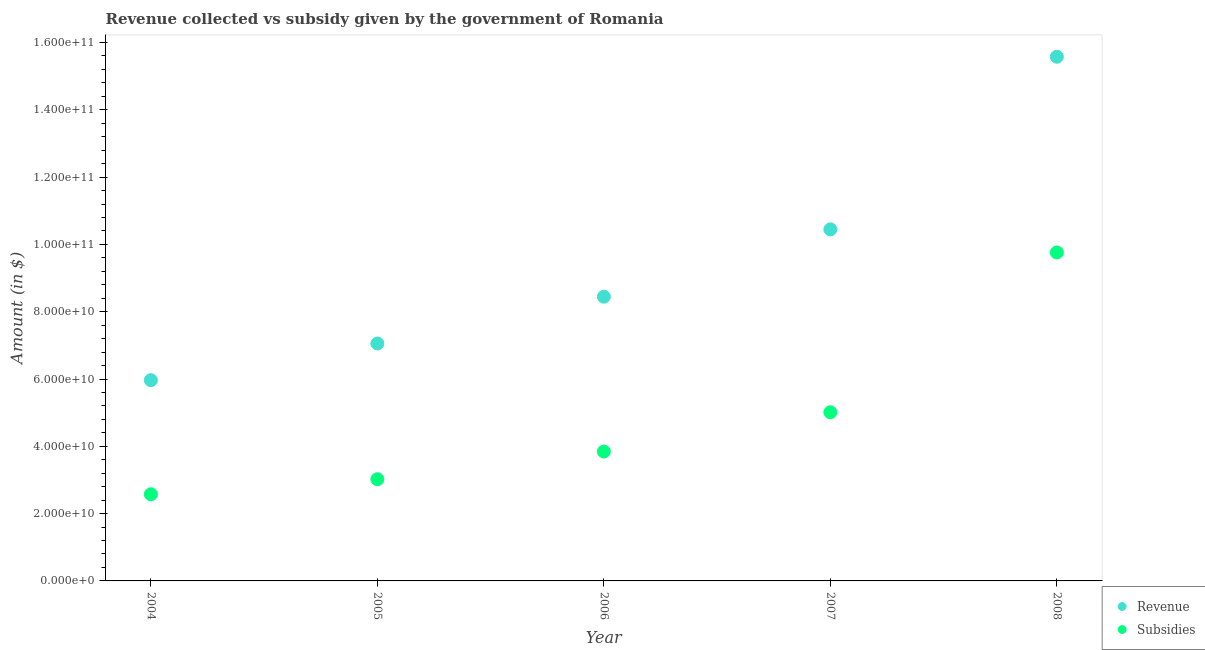How many different coloured dotlines are there?
Your answer should be very brief. 2. Is the number of dotlines equal to the number of legend labels?
Your answer should be very brief. Yes. What is the amount of subsidies given in 2007?
Offer a very short reply. 5.01e+1. Across all years, what is the maximum amount of subsidies given?
Your answer should be compact. 9.76e+1. Across all years, what is the minimum amount of subsidies given?
Ensure brevity in your answer.  2.57e+1. What is the total amount of subsidies given in the graph?
Your answer should be very brief. 2.42e+11. What is the difference between the amount of subsidies given in 2005 and that in 2008?
Provide a short and direct response. -6.74e+1. What is the difference between the amount of subsidies given in 2007 and the amount of revenue collected in 2004?
Your response must be concise. -9.53e+09. What is the average amount of subsidies given per year?
Your answer should be very brief. 4.84e+1. In the year 2006, what is the difference between the amount of revenue collected and amount of subsidies given?
Offer a very short reply. 4.60e+1. In how many years, is the amount of subsidies given greater than 68000000000 $?
Make the answer very short. 1. What is the ratio of the amount of subsidies given in 2006 to that in 2008?
Your response must be concise. 0.39. Is the difference between the amount of revenue collected in 2004 and 2005 greater than the difference between the amount of subsidies given in 2004 and 2005?
Your response must be concise. No. What is the difference between the highest and the second highest amount of subsidies given?
Your answer should be compact. 4.75e+1. What is the difference between the highest and the lowest amount of revenue collected?
Offer a very short reply. 9.61e+1. Does the amount of subsidies given monotonically increase over the years?
Offer a terse response. Yes. What is the difference between two consecutive major ticks on the Y-axis?
Make the answer very short. 2.00e+1. Where does the legend appear in the graph?
Your answer should be compact. Bottom right. What is the title of the graph?
Provide a succinct answer. Revenue collected vs subsidy given by the government of Romania. Does "Ages 15-24" appear as one of the legend labels in the graph?
Your answer should be compact. No. What is the label or title of the Y-axis?
Ensure brevity in your answer.  Amount (in $). What is the Amount (in $) in Revenue in 2004?
Your answer should be very brief. 5.96e+1. What is the Amount (in $) in Subsidies in 2004?
Provide a succinct answer. 2.57e+1. What is the Amount (in $) of Revenue in 2005?
Offer a terse response. 7.06e+1. What is the Amount (in $) of Subsidies in 2005?
Give a very brief answer. 3.02e+1. What is the Amount (in $) of Revenue in 2006?
Keep it short and to the point. 8.45e+1. What is the Amount (in $) in Subsidies in 2006?
Ensure brevity in your answer.  3.84e+1. What is the Amount (in $) of Revenue in 2007?
Your answer should be compact. 1.04e+11. What is the Amount (in $) of Subsidies in 2007?
Give a very brief answer. 5.01e+1. What is the Amount (in $) of Revenue in 2008?
Offer a terse response. 1.56e+11. What is the Amount (in $) of Subsidies in 2008?
Your answer should be very brief. 9.76e+1. Across all years, what is the maximum Amount (in $) in Revenue?
Keep it short and to the point. 1.56e+11. Across all years, what is the maximum Amount (in $) in Subsidies?
Offer a terse response. 9.76e+1. Across all years, what is the minimum Amount (in $) of Revenue?
Your answer should be very brief. 5.96e+1. Across all years, what is the minimum Amount (in $) of Subsidies?
Provide a succinct answer. 2.57e+1. What is the total Amount (in $) of Revenue in the graph?
Your response must be concise. 4.75e+11. What is the total Amount (in $) in Subsidies in the graph?
Make the answer very short. 2.42e+11. What is the difference between the Amount (in $) in Revenue in 2004 and that in 2005?
Your answer should be compact. -1.09e+1. What is the difference between the Amount (in $) of Subsidies in 2004 and that in 2005?
Your answer should be compact. -4.48e+09. What is the difference between the Amount (in $) of Revenue in 2004 and that in 2006?
Provide a succinct answer. -2.48e+1. What is the difference between the Amount (in $) in Subsidies in 2004 and that in 2006?
Give a very brief answer. -1.27e+1. What is the difference between the Amount (in $) of Revenue in 2004 and that in 2007?
Provide a short and direct response. -4.48e+1. What is the difference between the Amount (in $) of Subsidies in 2004 and that in 2007?
Make the answer very short. -2.44e+1. What is the difference between the Amount (in $) of Revenue in 2004 and that in 2008?
Offer a very short reply. -9.61e+1. What is the difference between the Amount (in $) of Subsidies in 2004 and that in 2008?
Your answer should be compact. -7.19e+1. What is the difference between the Amount (in $) in Revenue in 2005 and that in 2006?
Your answer should be compact. -1.39e+1. What is the difference between the Amount (in $) in Subsidies in 2005 and that in 2006?
Your answer should be compact. -8.22e+09. What is the difference between the Amount (in $) of Revenue in 2005 and that in 2007?
Your answer should be very brief. -3.39e+1. What is the difference between the Amount (in $) in Subsidies in 2005 and that in 2007?
Give a very brief answer. -1.99e+1. What is the difference between the Amount (in $) of Revenue in 2005 and that in 2008?
Offer a very short reply. -8.52e+1. What is the difference between the Amount (in $) of Subsidies in 2005 and that in 2008?
Keep it short and to the point. -6.74e+1. What is the difference between the Amount (in $) of Revenue in 2006 and that in 2007?
Your answer should be compact. -2.00e+1. What is the difference between the Amount (in $) of Subsidies in 2006 and that in 2007?
Your response must be concise. -1.17e+1. What is the difference between the Amount (in $) in Revenue in 2006 and that in 2008?
Offer a terse response. -7.13e+1. What is the difference between the Amount (in $) of Subsidies in 2006 and that in 2008?
Offer a very short reply. -5.92e+1. What is the difference between the Amount (in $) in Revenue in 2007 and that in 2008?
Your answer should be very brief. -5.13e+1. What is the difference between the Amount (in $) in Subsidies in 2007 and that in 2008?
Keep it short and to the point. -4.75e+1. What is the difference between the Amount (in $) in Revenue in 2004 and the Amount (in $) in Subsidies in 2005?
Your answer should be very brief. 2.94e+1. What is the difference between the Amount (in $) of Revenue in 2004 and the Amount (in $) of Subsidies in 2006?
Provide a succinct answer. 2.12e+1. What is the difference between the Amount (in $) of Revenue in 2004 and the Amount (in $) of Subsidies in 2007?
Provide a succinct answer. 9.53e+09. What is the difference between the Amount (in $) of Revenue in 2004 and the Amount (in $) of Subsidies in 2008?
Your answer should be compact. -3.80e+1. What is the difference between the Amount (in $) in Revenue in 2005 and the Amount (in $) in Subsidies in 2006?
Offer a very short reply. 3.21e+1. What is the difference between the Amount (in $) of Revenue in 2005 and the Amount (in $) of Subsidies in 2007?
Make the answer very short. 2.04e+1. What is the difference between the Amount (in $) of Revenue in 2005 and the Amount (in $) of Subsidies in 2008?
Provide a succinct answer. -2.71e+1. What is the difference between the Amount (in $) in Revenue in 2006 and the Amount (in $) in Subsidies in 2007?
Your response must be concise. 3.43e+1. What is the difference between the Amount (in $) in Revenue in 2006 and the Amount (in $) in Subsidies in 2008?
Ensure brevity in your answer.  -1.31e+1. What is the difference between the Amount (in $) of Revenue in 2007 and the Amount (in $) of Subsidies in 2008?
Provide a short and direct response. 6.87e+09. What is the average Amount (in $) in Revenue per year?
Your response must be concise. 9.50e+1. What is the average Amount (in $) of Subsidies per year?
Keep it short and to the point. 4.84e+1. In the year 2004, what is the difference between the Amount (in $) in Revenue and Amount (in $) in Subsidies?
Provide a succinct answer. 3.39e+1. In the year 2005, what is the difference between the Amount (in $) of Revenue and Amount (in $) of Subsidies?
Offer a terse response. 4.03e+1. In the year 2006, what is the difference between the Amount (in $) in Revenue and Amount (in $) in Subsidies?
Offer a very short reply. 4.60e+1. In the year 2007, what is the difference between the Amount (in $) of Revenue and Amount (in $) of Subsidies?
Keep it short and to the point. 5.44e+1. In the year 2008, what is the difference between the Amount (in $) of Revenue and Amount (in $) of Subsidies?
Your response must be concise. 5.82e+1. What is the ratio of the Amount (in $) in Revenue in 2004 to that in 2005?
Ensure brevity in your answer.  0.85. What is the ratio of the Amount (in $) of Subsidies in 2004 to that in 2005?
Your response must be concise. 0.85. What is the ratio of the Amount (in $) of Revenue in 2004 to that in 2006?
Your answer should be very brief. 0.71. What is the ratio of the Amount (in $) of Subsidies in 2004 to that in 2006?
Provide a short and direct response. 0.67. What is the ratio of the Amount (in $) of Revenue in 2004 to that in 2007?
Make the answer very short. 0.57. What is the ratio of the Amount (in $) of Subsidies in 2004 to that in 2007?
Provide a succinct answer. 0.51. What is the ratio of the Amount (in $) in Revenue in 2004 to that in 2008?
Your response must be concise. 0.38. What is the ratio of the Amount (in $) in Subsidies in 2004 to that in 2008?
Keep it short and to the point. 0.26. What is the ratio of the Amount (in $) in Revenue in 2005 to that in 2006?
Keep it short and to the point. 0.84. What is the ratio of the Amount (in $) in Subsidies in 2005 to that in 2006?
Provide a short and direct response. 0.79. What is the ratio of the Amount (in $) of Revenue in 2005 to that in 2007?
Give a very brief answer. 0.68. What is the ratio of the Amount (in $) of Subsidies in 2005 to that in 2007?
Give a very brief answer. 0.6. What is the ratio of the Amount (in $) in Revenue in 2005 to that in 2008?
Your answer should be very brief. 0.45. What is the ratio of the Amount (in $) of Subsidies in 2005 to that in 2008?
Your response must be concise. 0.31. What is the ratio of the Amount (in $) in Revenue in 2006 to that in 2007?
Provide a succinct answer. 0.81. What is the ratio of the Amount (in $) of Subsidies in 2006 to that in 2007?
Give a very brief answer. 0.77. What is the ratio of the Amount (in $) in Revenue in 2006 to that in 2008?
Keep it short and to the point. 0.54. What is the ratio of the Amount (in $) of Subsidies in 2006 to that in 2008?
Your answer should be compact. 0.39. What is the ratio of the Amount (in $) in Revenue in 2007 to that in 2008?
Your answer should be very brief. 0.67. What is the ratio of the Amount (in $) of Subsidies in 2007 to that in 2008?
Provide a short and direct response. 0.51. What is the difference between the highest and the second highest Amount (in $) in Revenue?
Ensure brevity in your answer.  5.13e+1. What is the difference between the highest and the second highest Amount (in $) of Subsidies?
Your answer should be very brief. 4.75e+1. What is the difference between the highest and the lowest Amount (in $) of Revenue?
Offer a terse response. 9.61e+1. What is the difference between the highest and the lowest Amount (in $) in Subsidies?
Your answer should be very brief. 7.19e+1. 